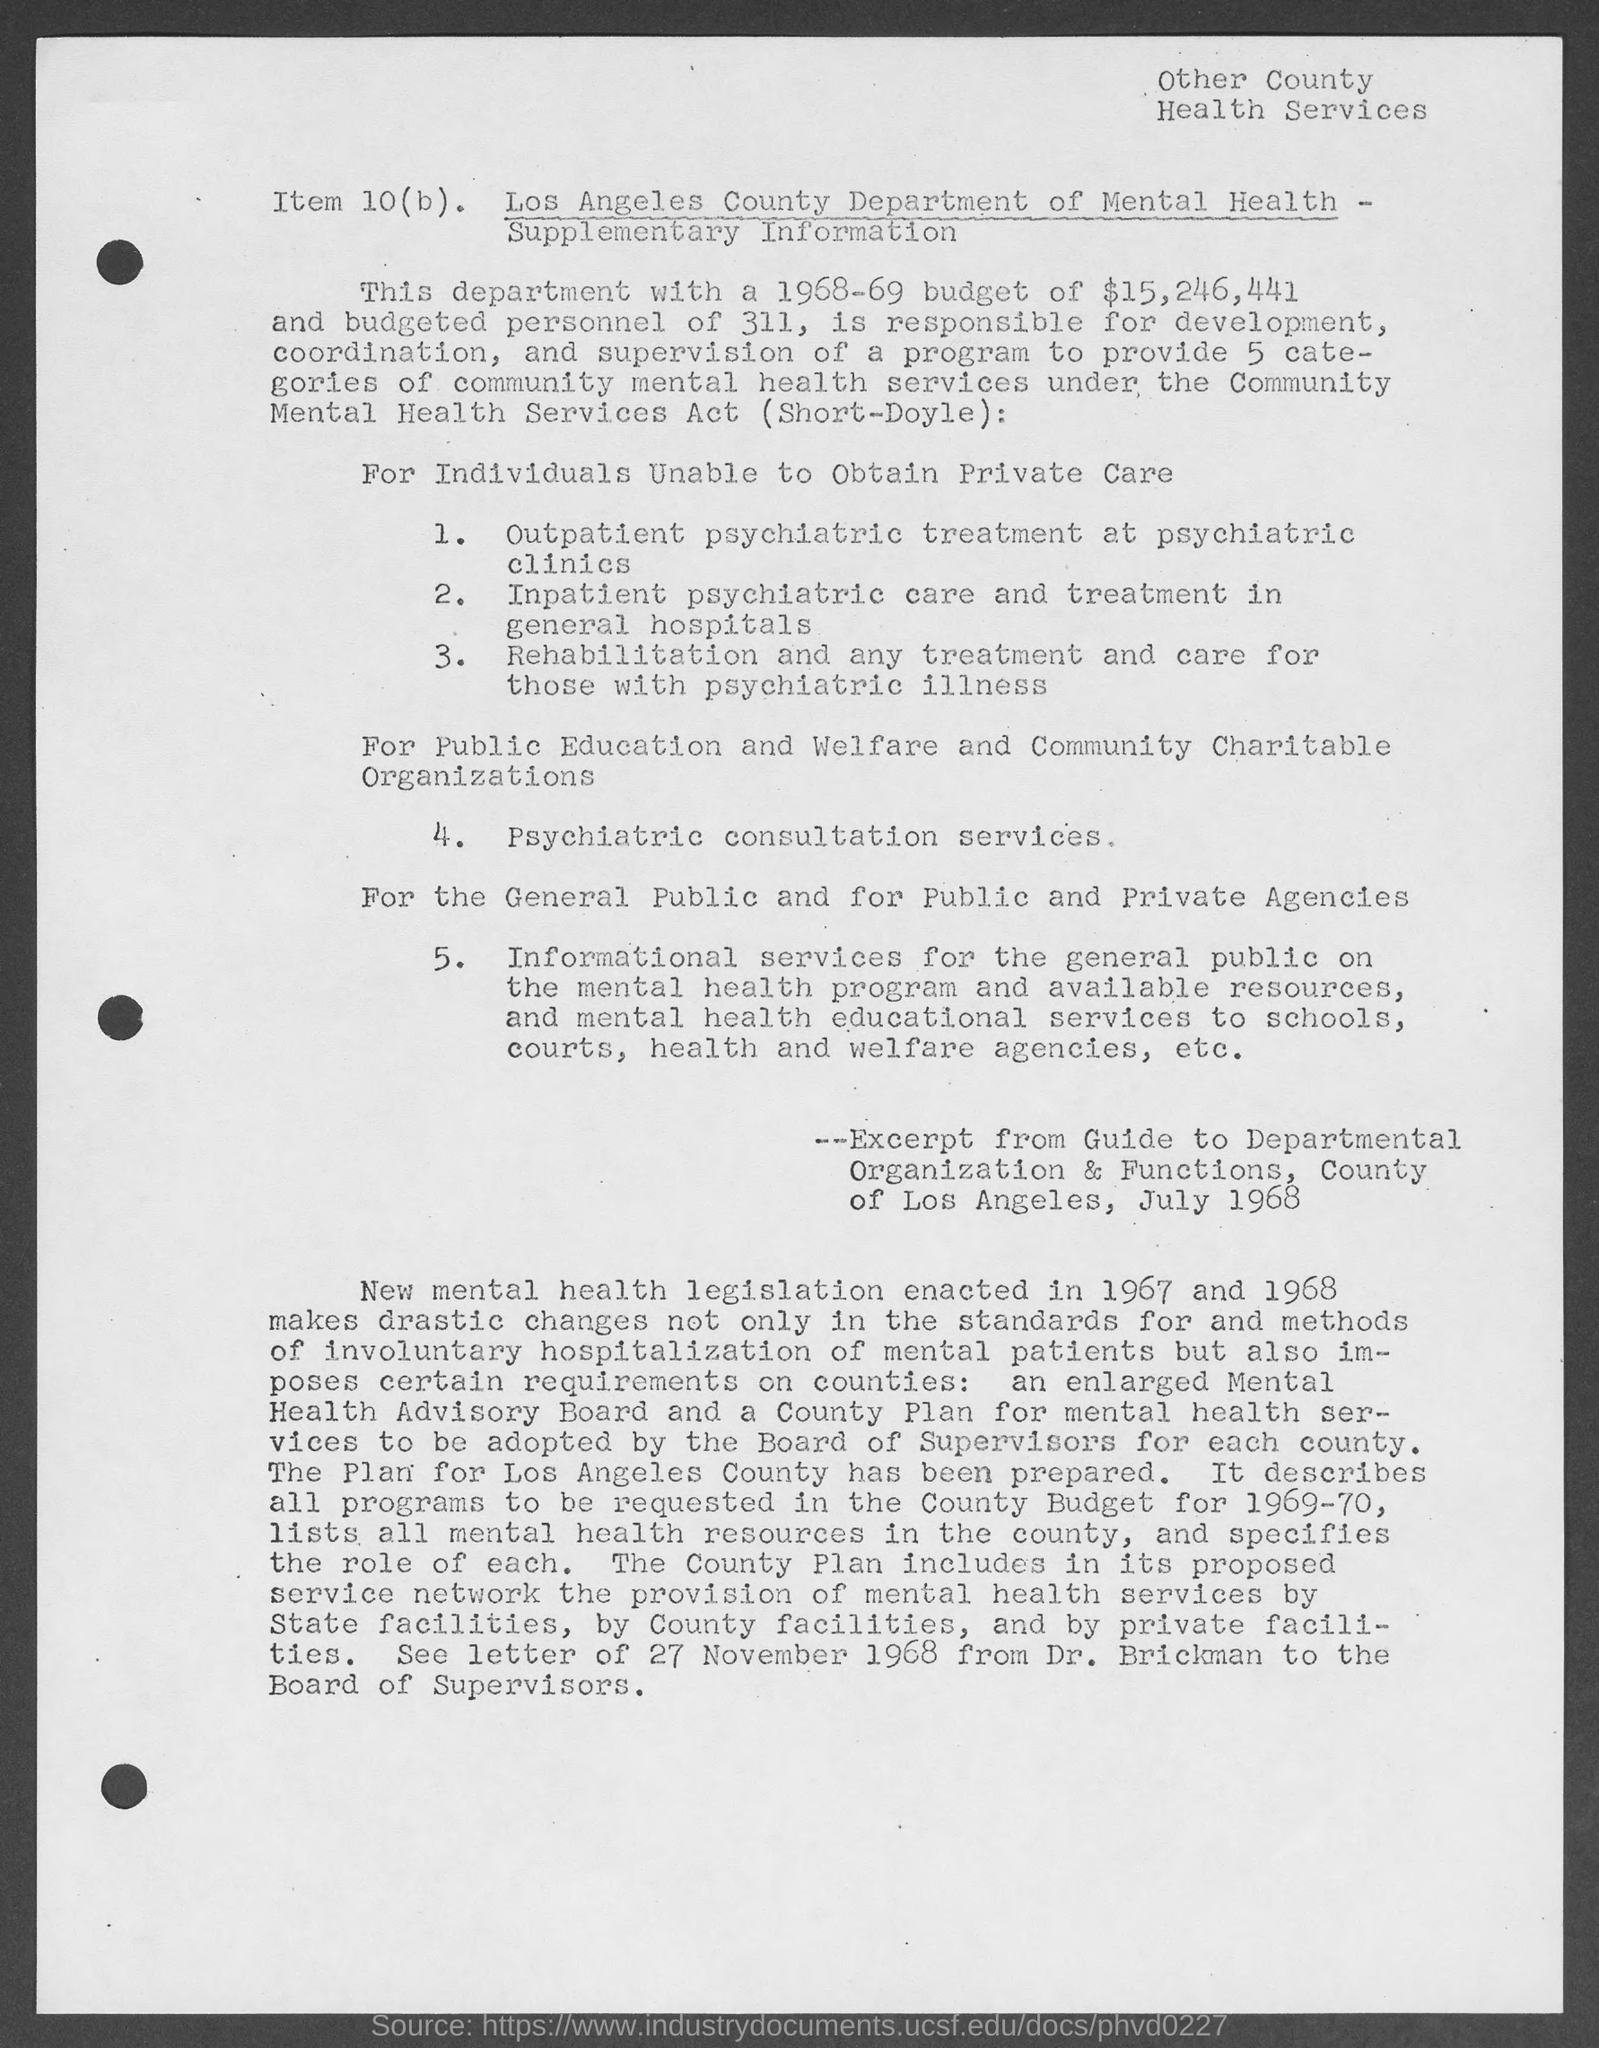Outline some significant characteristics in this image. The budget for the department is $15,246,441. The Los Angeles County Department of Mental Health is commonly referred to as the Mental Health department. The document reads "Other County Health Services" at the top-right. For individuals who are unable to obtain private care, the fourth point mentioned is psychiatric consultation services. 